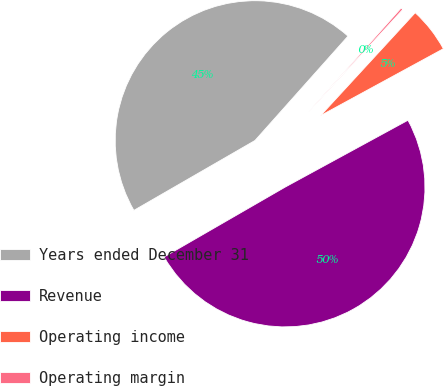<chart> <loc_0><loc_0><loc_500><loc_500><pie_chart><fcel>Years ended December 31<fcel>Revenue<fcel>Operating income<fcel>Operating margin<nl><fcel>44.92%<fcel>49.61%<fcel>5.23%<fcel>0.25%<nl></chart> 